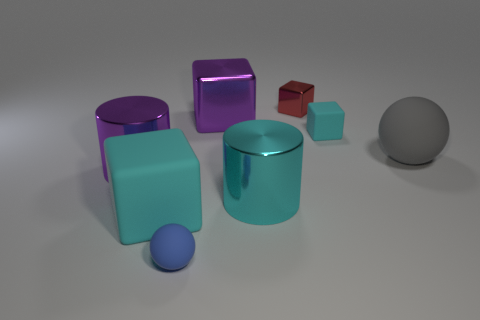Subtract 2 cubes. How many cubes are left? 2 Subtract all gray cubes. Subtract all gray spheres. How many cubes are left? 4 Add 1 rubber objects. How many objects exist? 9 Subtract all cylinders. How many objects are left? 6 Subtract all big purple blocks. Subtract all brown matte cubes. How many objects are left? 7 Add 1 large cyan matte cubes. How many large cyan matte cubes are left? 2 Add 4 big things. How many big things exist? 9 Subtract 0 green blocks. How many objects are left? 8 